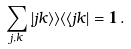Convert formula to latex. <formula><loc_0><loc_0><loc_500><loc_500>\sum _ { j , k } | j k \rangle \rangle \langle \langle j k | = { \mathbf 1 } \, .</formula> 